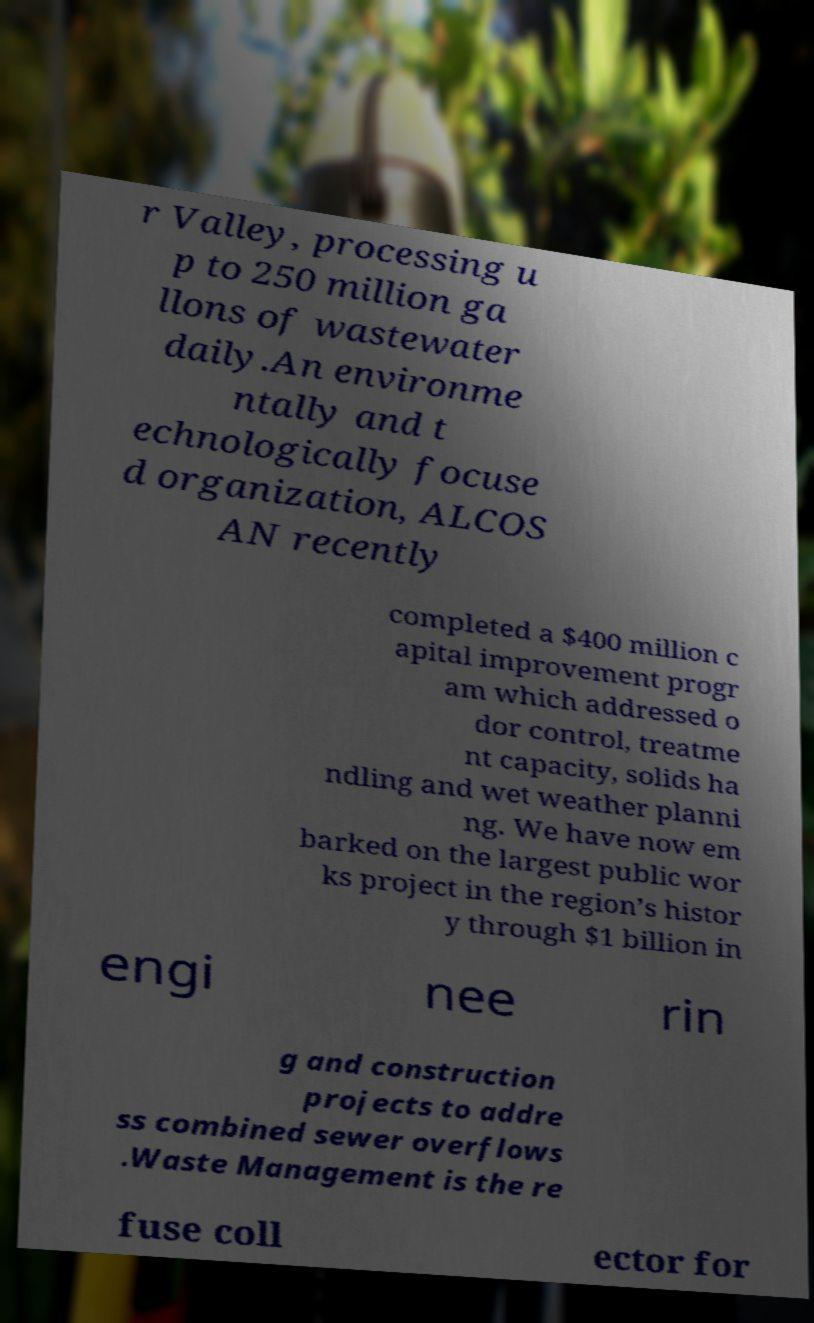For documentation purposes, I need the text within this image transcribed. Could you provide that? r Valley, processing u p to 250 million ga llons of wastewater daily.An environme ntally and t echnologically focuse d organization, ALCOS AN recently completed a $400 million c apital improvement progr am which addressed o dor control, treatme nt capacity, solids ha ndling and wet weather planni ng. We have now em barked on the largest public wor ks project in the region’s histor y through $1 billion in engi nee rin g and construction projects to addre ss combined sewer overflows .Waste Management is the re fuse coll ector for 